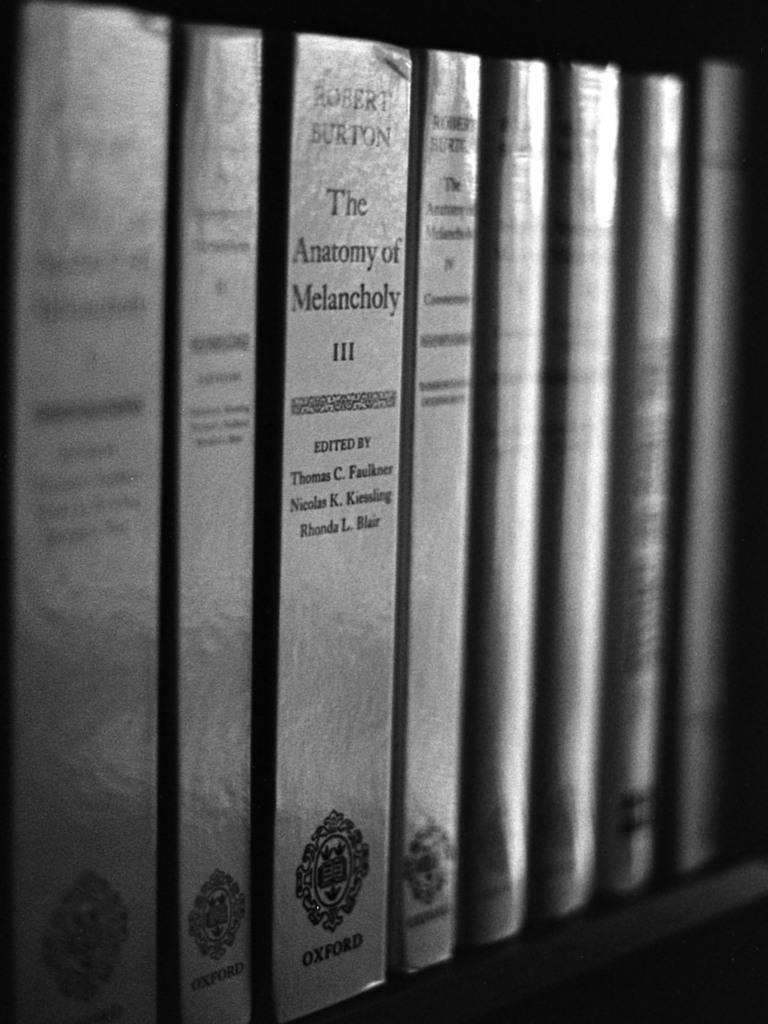What is the title of this book?
Provide a short and direct response. The anatomy of melancholy. Whos is the author of the 3rd book?
Give a very brief answer. Robert burton. 